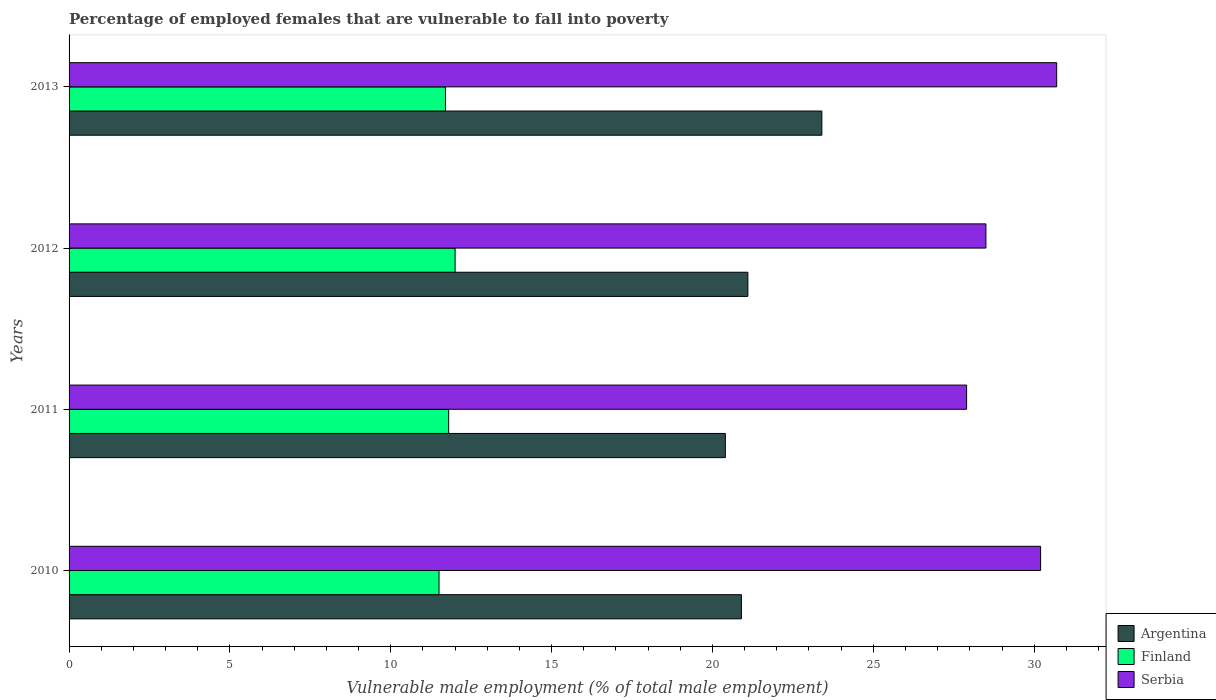How many different coloured bars are there?
Provide a succinct answer. 3. Are the number of bars on each tick of the Y-axis equal?
Provide a short and direct response. Yes. How many bars are there on the 4th tick from the top?
Provide a succinct answer. 3. How many bars are there on the 1st tick from the bottom?
Provide a succinct answer. 3. What is the percentage of employed females who are vulnerable to fall into poverty in Finland in 2010?
Give a very brief answer. 11.5. Across all years, what is the minimum percentage of employed females who are vulnerable to fall into poverty in Finland?
Your answer should be very brief. 11.5. In which year was the percentage of employed females who are vulnerable to fall into poverty in Argentina maximum?
Ensure brevity in your answer.  2013. What is the total percentage of employed females who are vulnerable to fall into poverty in Serbia in the graph?
Your answer should be compact. 117.3. What is the difference between the percentage of employed females who are vulnerable to fall into poverty in Finland in 2010 and that in 2013?
Give a very brief answer. -0.2. What is the difference between the percentage of employed females who are vulnerable to fall into poverty in Argentina in 2010 and the percentage of employed females who are vulnerable to fall into poverty in Finland in 2012?
Keep it short and to the point. 8.9. What is the average percentage of employed females who are vulnerable to fall into poverty in Argentina per year?
Offer a very short reply. 21.45. In the year 2013, what is the difference between the percentage of employed females who are vulnerable to fall into poverty in Serbia and percentage of employed females who are vulnerable to fall into poverty in Argentina?
Give a very brief answer. 7.3. What is the ratio of the percentage of employed females who are vulnerable to fall into poverty in Finland in 2012 to that in 2013?
Offer a terse response. 1.03. Is the percentage of employed females who are vulnerable to fall into poverty in Argentina in 2010 less than that in 2013?
Ensure brevity in your answer.  Yes. What is the difference between the highest and the second highest percentage of employed females who are vulnerable to fall into poverty in Serbia?
Ensure brevity in your answer.  0.5. What is the difference between the highest and the lowest percentage of employed females who are vulnerable to fall into poverty in Serbia?
Your answer should be very brief. 2.8. In how many years, is the percentage of employed females who are vulnerable to fall into poverty in Argentina greater than the average percentage of employed females who are vulnerable to fall into poverty in Argentina taken over all years?
Your answer should be compact. 1. What does the 3rd bar from the top in 2011 represents?
Give a very brief answer. Argentina. What does the 3rd bar from the bottom in 2012 represents?
Keep it short and to the point. Serbia. Are all the bars in the graph horizontal?
Make the answer very short. Yes. How many years are there in the graph?
Your response must be concise. 4. What is the difference between two consecutive major ticks on the X-axis?
Your answer should be very brief. 5. Does the graph contain any zero values?
Provide a short and direct response. No. How many legend labels are there?
Ensure brevity in your answer.  3. How are the legend labels stacked?
Provide a succinct answer. Vertical. What is the title of the graph?
Your response must be concise. Percentage of employed females that are vulnerable to fall into poverty. What is the label or title of the X-axis?
Ensure brevity in your answer.  Vulnerable male employment (% of total male employment). What is the Vulnerable male employment (% of total male employment) in Argentina in 2010?
Your response must be concise. 20.9. What is the Vulnerable male employment (% of total male employment) of Finland in 2010?
Ensure brevity in your answer.  11.5. What is the Vulnerable male employment (% of total male employment) of Serbia in 2010?
Your response must be concise. 30.2. What is the Vulnerable male employment (% of total male employment) of Argentina in 2011?
Make the answer very short. 20.4. What is the Vulnerable male employment (% of total male employment) in Finland in 2011?
Give a very brief answer. 11.8. What is the Vulnerable male employment (% of total male employment) in Serbia in 2011?
Offer a very short reply. 27.9. What is the Vulnerable male employment (% of total male employment) in Argentina in 2012?
Provide a succinct answer. 21.1. What is the Vulnerable male employment (% of total male employment) in Finland in 2012?
Offer a very short reply. 12. What is the Vulnerable male employment (% of total male employment) in Serbia in 2012?
Your answer should be very brief. 28.5. What is the Vulnerable male employment (% of total male employment) of Argentina in 2013?
Provide a short and direct response. 23.4. What is the Vulnerable male employment (% of total male employment) of Finland in 2013?
Offer a terse response. 11.7. What is the Vulnerable male employment (% of total male employment) in Serbia in 2013?
Offer a terse response. 30.7. Across all years, what is the maximum Vulnerable male employment (% of total male employment) of Argentina?
Your response must be concise. 23.4. Across all years, what is the maximum Vulnerable male employment (% of total male employment) of Serbia?
Keep it short and to the point. 30.7. Across all years, what is the minimum Vulnerable male employment (% of total male employment) of Argentina?
Your answer should be very brief. 20.4. Across all years, what is the minimum Vulnerable male employment (% of total male employment) in Serbia?
Your answer should be very brief. 27.9. What is the total Vulnerable male employment (% of total male employment) in Argentina in the graph?
Your response must be concise. 85.8. What is the total Vulnerable male employment (% of total male employment) in Finland in the graph?
Your response must be concise. 47. What is the total Vulnerable male employment (% of total male employment) in Serbia in the graph?
Your answer should be compact. 117.3. What is the difference between the Vulnerable male employment (% of total male employment) in Argentina in 2010 and that in 2011?
Provide a short and direct response. 0.5. What is the difference between the Vulnerable male employment (% of total male employment) in Finland in 2010 and that in 2012?
Give a very brief answer. -0.5. What is the difference between the Vulnerable male employment (% of total male employment) in Serbia in 2010 and that in 2012?
Your answer should be compact. 1.7. What is the difference between the Vulnerable male employment (% of total male employment) of Argentina in 2011 and that in 2012?
Offer a very short reply. -0.7. What is the difference between the Vulnerable male employment (% of total male employment) of Finland in 2011 and that in 2012?
Your answer should be very brief. -0.2. What is the difference between the Vulnerable male employment (% of total male employment) of Argentina in 2011 and that in 2013?
Make the answer very short. -3. What is the difference between the Vulnerable male employment (% of total male employment) in Finland in 2011 and that in 2013?
Give a very brief answer. 0.1. What is the difference between the Vulnerable male employment (% of total male employment) in Serbia in 2011 and that in 2013?
Your answer should be compact. -2.8. What is the difference between the Vulnerable male employment (% of total male employment) in Finland in 2012 and that in 2013?
Give a very brief answer. 0.3. What is the difference between the Vulnerable male employment (% of total male employment) in Finland in 2010 and the Vulnerable male employment (% of total male employment) in Serbia in 2011?
Ensure brevity in your answer.  -16.4. What is the difference between the Vulnerable male employment (% of total male employment) of Argentina in 2010 and the Vulnerable male employment (% of total male employment) of Finland in 2012?
Your answer should be very brief. 8.9. What is the difference between the Vulnerable male employment (% of total male employment) of Finland in 2010 and the Vulnerable male employment (% of total male employment) of Serbia in 2012?
Offer a very short reply. -17. What is the difference between the Vulnerable male employment (% of total male employment) of Argentina in 2010 and the Vulnerable male employment (% of total male employment) of Finland in 2013?
Offer a terse response. 9.2. What is the difference between the Vulnerable male employment (% of total male employment) in Finland in 2010 and the Vulnerable male employment (% of total male employment) in Serbia in 2013?
Your answer should be compact. -19.2. What is the difference between the Vulnerable male employment (% of total male employment) in Argentina in 2011 and the Vulnerable male employment (% of total male employment) in Serbia in 2012?
Provide a succinct answer. -8.1. What is the difference between the Vulnerable male employment (% of total male employment) of Finland in 2011 and the Vulnerable male employment (% of total male employment) of Serbia in 2012?
Your answer should be compact. -16.7. What is the difference between the Vulnerable male employment (% of total male employment) of Argentina in 2011 and the Vulnerable male employment (% of total male employment) of Finland in 2013?
Ensure brevity in your answer.  8.7. What is the difference between the Vulnerable male employment (% of total male employment) of Finland in 2011 and the Vulnerable male employment (% of total male employment) of Serbia in 2013?
Make the answer very short. -18.9. What is the difference between the Vulnerable male employment (% of total male employment) in Finland in 2012 and the Vulnerable male employment (% of total male employment) in Serbia in 2013?
Your answer should be compact. -18.7. What is the average Vulnerable male employment (% of total male employment) in Argentina per year?
Ensure brevity in your answer.  21.45. What is the average Vulnerable male employment (% of total male employment) of Finland per year?
Your answer should be very brief. 11.75. What is the average Vulnerable male employment (% of total male employment) in Serbia per year?
Your answer should be very brief. 29.32. In the year 2010, what is the difference between the Vulnerable male employment (% of total male employment) of Argentina and Vulnerable male employment (% of total male employment) of Serbia?
Provide a succinct answer. -9.3. In the year 2010, what is the difference between the Vulnerable male employment (% of total male employment) of Finland and Vulnerable male employment (% of total male employment) of Serbia?
Keep it short and to the point. -18.7. In the year 2011, what is the difference between the Vulnerable male employment (% of total male employment) of Finland and Vulnerable male employment (% of total male employment) of Serbia?
Your answer should be very brief. -16.1. In the year 2012, what is the difference between the Vulnerable male employment (% of total male employment) of Argentina and Vulnerable male employment (% of total male employment) of Finland?
Ensure brevity in your answer.  9.1. In the year 2012, what is the difference between the Vulnerable male employment (% of total male employment) in Argentina and Vulnerable male employment (% of total male employment) in Serbia?
Your answer should be compact. -7.4. In the year 2012, what is the difference between the Vulnerable male employment (% of total male employment) of Finland and Vulnerable male employment (% of total male employment) of Serbia?
Give a very brief answer. -16.5. In the year 2013, what is the difference between the Vulnerable male employment (% of total male employment) of Argentina and Vulnerable male employment (% of total male employment) of Finland?
Make the answer very short. 11.7. In the year 2013, what is the difference between the Vulnerable male employment (% of total male employment) of Argentina and Vulnerable male employment (% of total male employment) of Serbia?
Keep it short and to the point. -7.3. In the year 2013, what is the difference between the Vulnerable male employment (% of total male employment) in Finland and Vulnerable male employment (% of total male employment) in Serbia?
Offer a very short reply. -19. What is the ratio of the Vulnerable male employment (% of total male employment) in Argentina in 2010 to that in 2011?
Offer a very short reply. 1.02. What is the ratio of the Vulnerable male employment (% of total male employment) in Finland in 2010 to that in 2011?
Give a very brief answer. 0.97. What is the ratio of the Vulnerable male employment (% of total male employment) in Serbia in 2010 to that in 2011?
Your answer should be very brief. 1.08. What is the ratio of the Vulnerable male employment (% of total male employment) of Serbia in 2010 to that in 2012?
Keep it short and to the point. 1.06. What is the ratio of the Vulnerable male employment (% of total male employment) in Argentina in 2010 to that in 2013?
Provide a short and direct response. 0.89. What is the ratio of the Vulnerable male employment (% of total male employment) in Finland in 2010 to that in 2013?
Provide a succinct answer. 0.98. What is the ratio of the Vulnerable male employment (% of total male employment) in Serbia in 2010 to that in 2013?
Your answer should be compact. 0.98. What is the ratio of the Vulnerable male employment (% of total male employment) in Argentina in 2011 to that in 2012?
Offer a very short reply. 0.97. What is the ratio of the Vulnerable male employment (% of total male employment) in Finland in 2011 to that in 2012?
Offer a very short reply. 0.98. What is the ratio of the Vulnerable male employment (% of total male employment) in Serbia in 2011 to that in 2012?
Your answer should be compact. 0.98. What is the ratio of the Vulnerable male employment (% of total male employment) in Argentina in 2011 to that in 2013?
Your response must be concise. 0.87. What is the ratio of the Vulnerable male employment (% of total male employment) in Finland in 2011 to that in 2013?
Offer a very short reply. 1.01. What is the ratio of the Vulnerable male employment (% of total male employment) of Serbia in 2011 to that in 2013?
Your response must be concise. 0.91. What is the ratio of the Vulnerable male employment (% of total male employment) of Argentina in 2012 to that in 2013?
Your response must be concise. 0.9. What is the ratio of the Vulnerable male employment (% of total male employment) of Finland in 2012 to that in 2013?
Your response must be concise. 1.03. What is the ratio of the Vulnerable male employment (% of total male employment) of Serbia in 2012 to that in 2013?
Make the answer very short. 0.93. What is the difference between the highest and the second highest Vulnerable male employment (% of total male employment) of Argentina?
Make the answer very short. 2.3. What is the difference between the highest and the lowest Vulnerable male employment (% of total male employment) of Finland?
Ensure brevity in your answer.  0.5. 